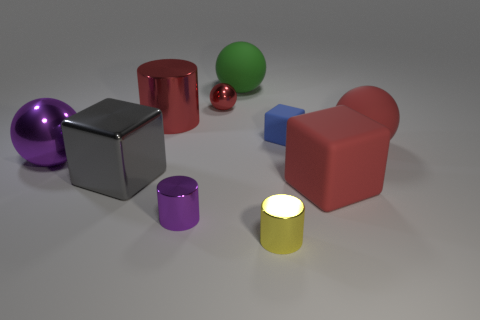Subtract all yellow cylinders. How many red spheres are left? 2 Subtract all gray metal cubes. How many cubes are left? 2 Subtract all purple balls. How many balls are left? 3 Subtract all cylinders. How many objects are left? 7 Subtract 2 cylinders. How many cylinders are left? 1 Add 2 small blue cubes. How many small blue cubes are left? 3 Add 8 small green shiny cubes. How many small green shiny cubes exist? 8 Subtract 1 blue blocks. How many objects are left? 9 Subtract all brown blocks. Subtract all brown cylinders. How many blocks are left? 3 Subtract all brown metallic cylinders. Subtract all purple shiny cylinders. How many objects are left? 9 